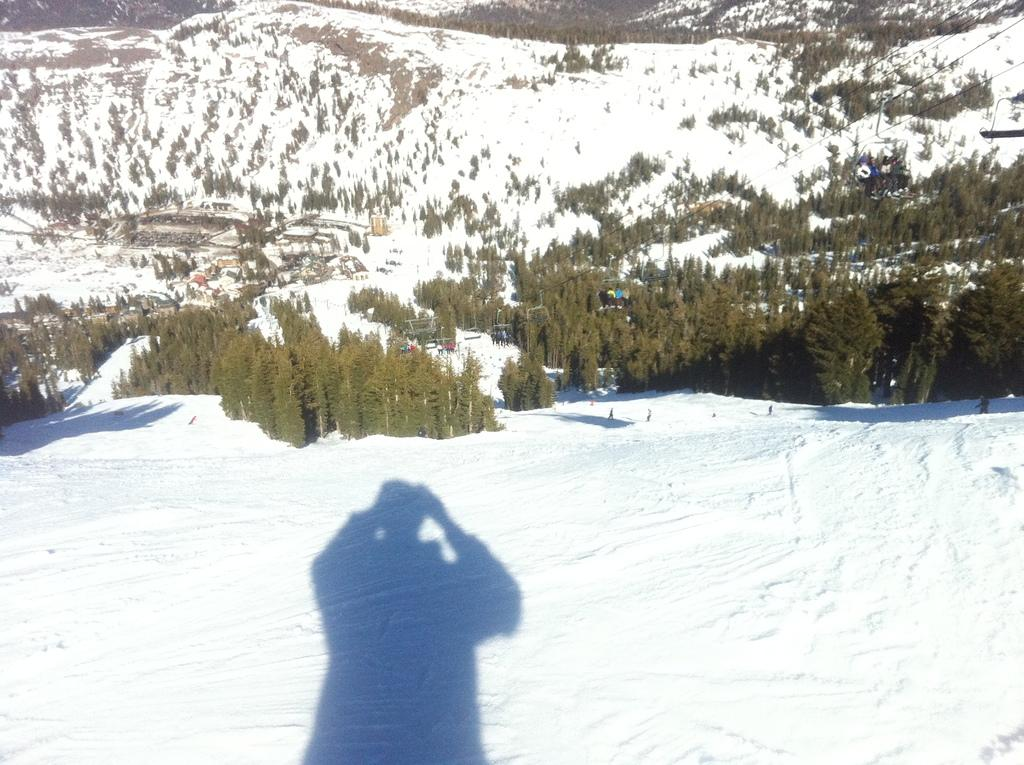What is happening on the right side of the image? There are persons on the snow at the right side of the image. What can be seen in the background of the image? There are trees in the background of the image. How is the land in the background of the image? The land in the background of the image is covered with snow. What type of lip can be seen on the trees in the image? There are no lips present on the trees in the image; they are simply trees with branches and leaves. What kind of punishment is being administered to the persons on the snow in the image? There is no indication of any punishment being administered to the persons in the image; they are simply standing or walking on the snow. 